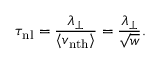Convert formula to latex. <formula><loc_0><loc_0><loc_500><loc_500>\tau _ { n l } = \frac { \lambda _ { \perp } } { \langle v _ { n t h } \rangle } = \frac { \lambda _ { \perp } } { \sqrt { w } } .</formula> 